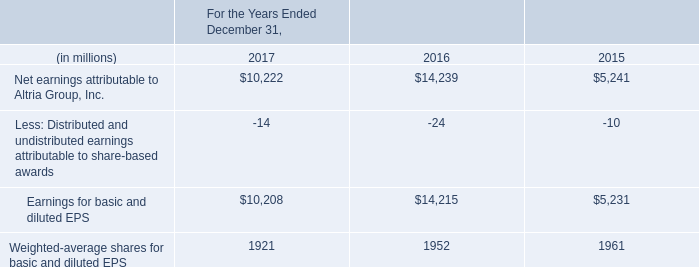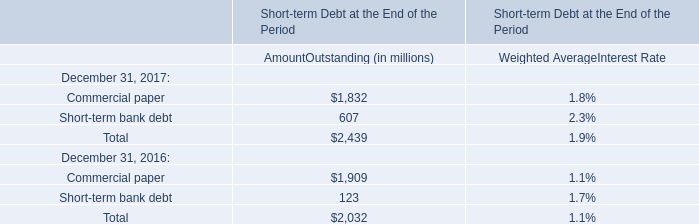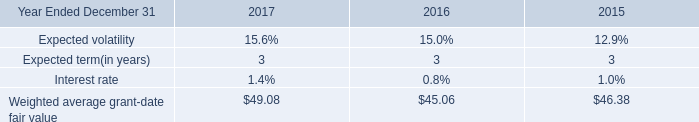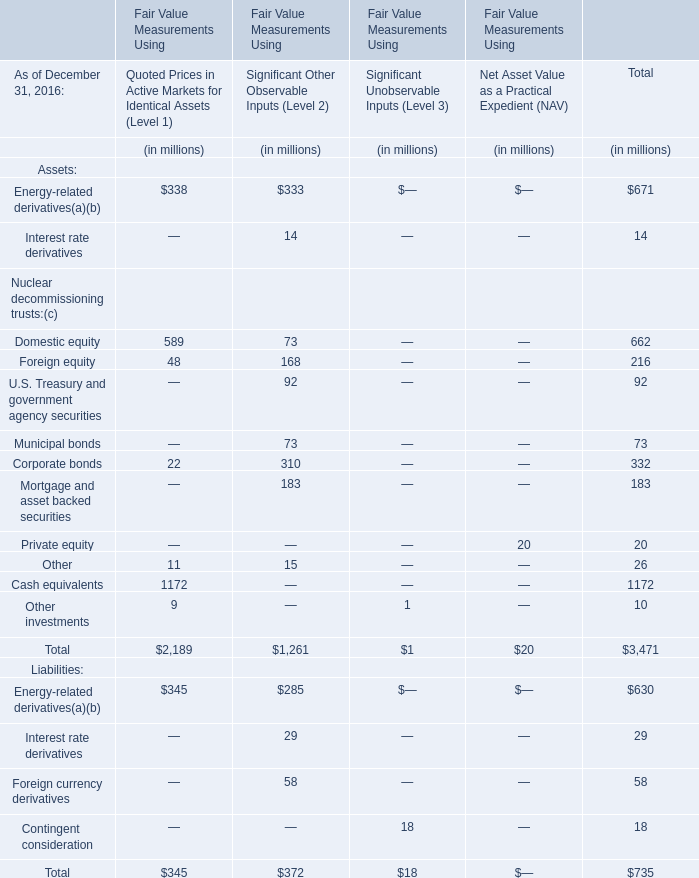Does the proportion of Energy-related derivatives in total larger than that of Domestic equity in 2016 for Quoted Prices in Active Markets for Identical Assets (Level 1)? 
Answer: no. 